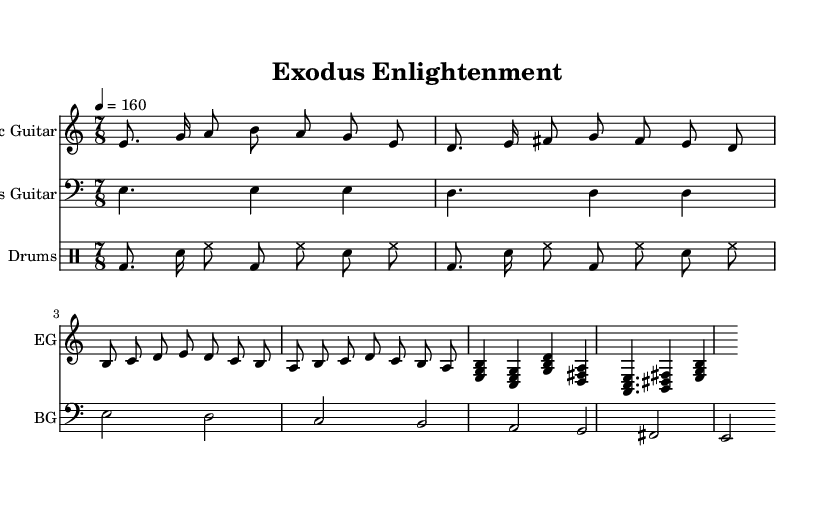What is the key signature of this music? The key signature is based on the global setting in the code, which indicates the use of E Phrygian, which traditionally has no sharps or flats.
Answer: E Phrygian What is the time signature of this music? The time signature is specified in the global settings. The notation "7/8" indicates that there are seven eighth notes per measure.
Answer: 7/8 What is the tempo of this music? The tempo is indicated by "4 = 160", which means there are 160 beats per minute, corresponding to a quarter note being equal to this value.
Answer: 160 How many measures are in the main riff? By examining the electric guitar part, the main riff consists of two measures as it is directly indicated in the structure of the music.
Answer: 2 What type of guitar is featured prominently in this piece? The instrument name in the electric guitar section states "Electric Guitar," thus confirming the type of guitar used in this progressive metal piece.
Answer: Electric Guitar What kind of rhythm is the drum part based on? The drum part is primarily indicated using a combination of bass drums, snare, and hi-hat in a driving rhythmic pattern, typical of metal genres.
Answer: Driving rhythm What is the structure of the piece based on the sections provided? The structure of the piece includes a main riff, a verse, a chorus, and a bridge with distinctive melodic and rhythmic motifs, characteristic of progressive metal.
Answer: Main riff, verse, chorus, bridge 